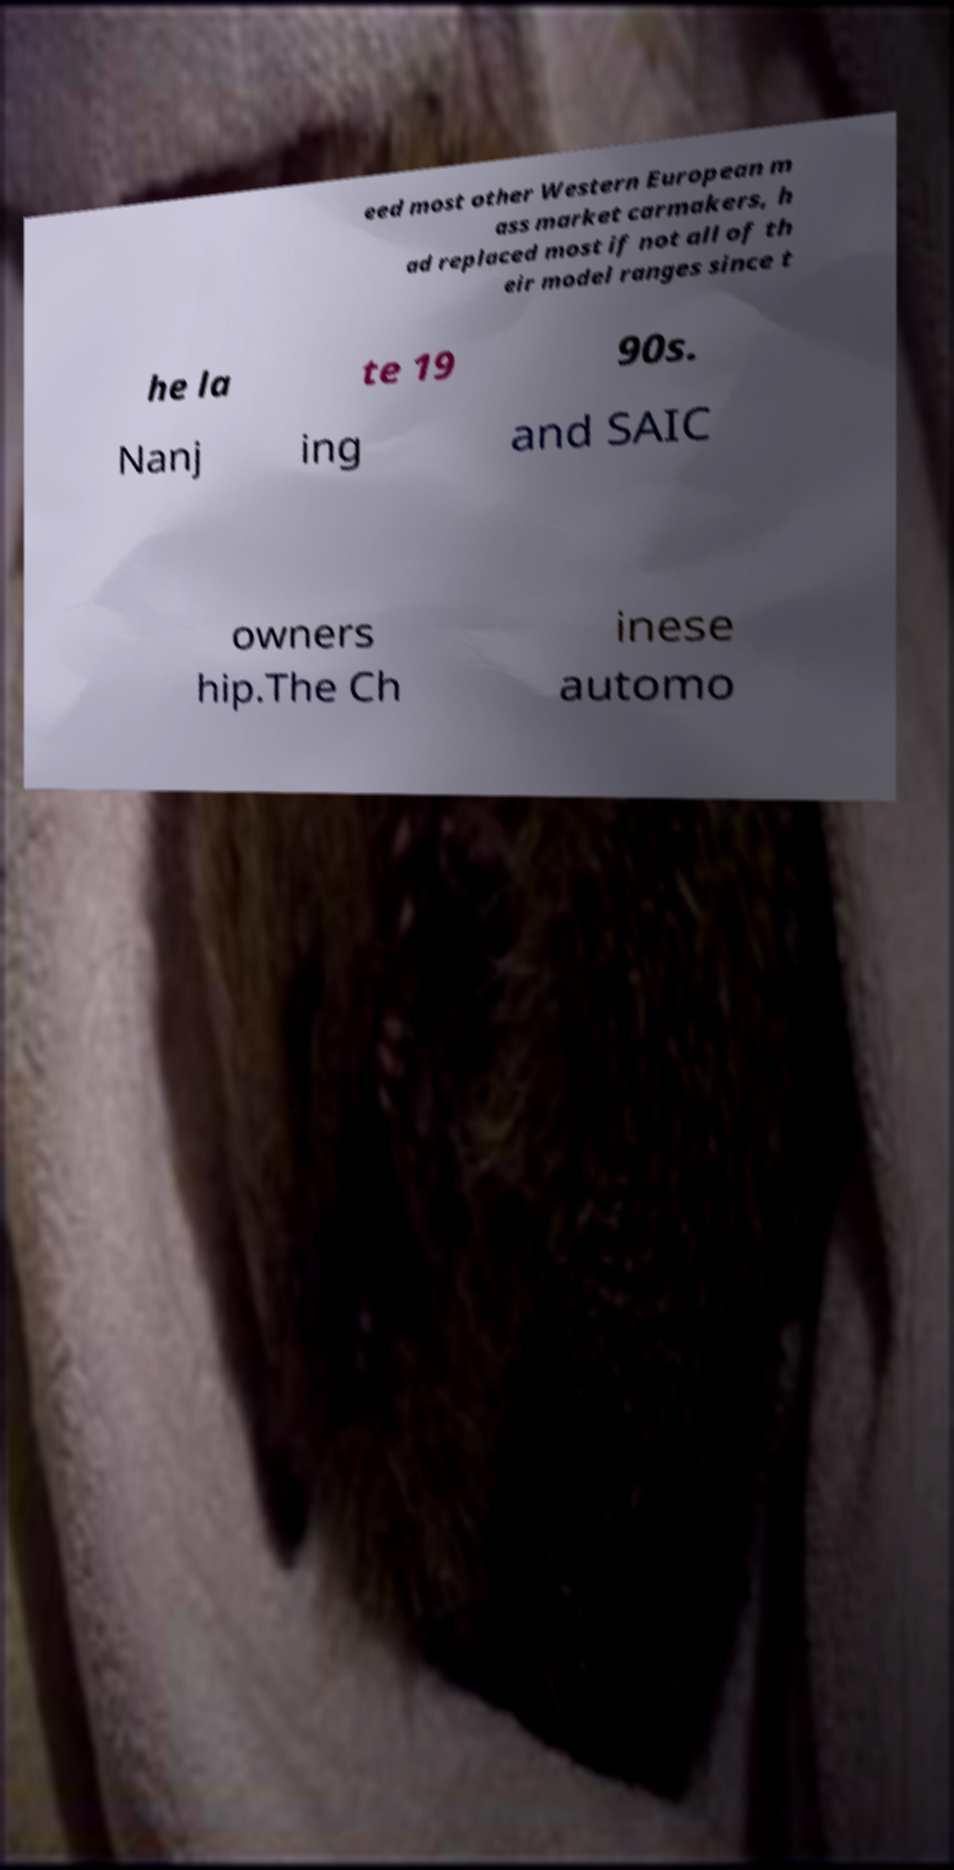Please read and relay the text visible in this image. What does it say? eed most other Western European m ass market carmakers, h ad replaced most if not all of th eir model ranges since t he la te 19 90s. Nanj ing and SAIC owners hip.The Ch inese automo 